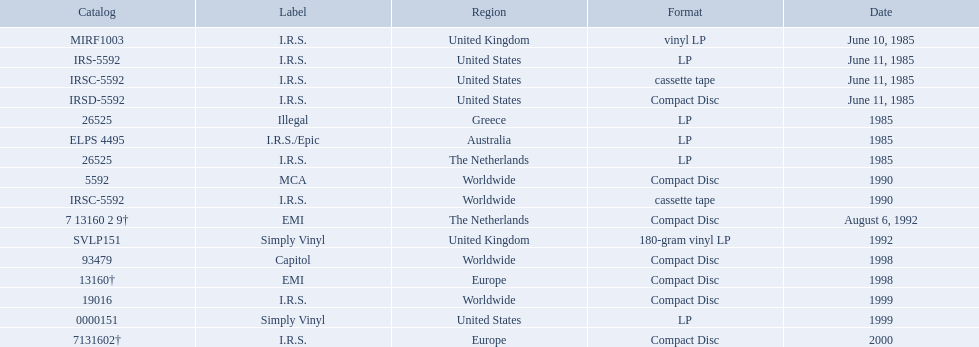Which dates were their releases by fables of the reconstruction? June 10, 1985, June 11, 1985, June 11, 1985, June 11, 1985, 1985, 1985, 1985, 1990, 1990, August 6, 1992, 1992, 1998, 1998, 1999, 1999, 2000. Which of these are in 1985? June 10, 1985, June 11, 1985, June 11, 1985, June 11, 1985, 1985, 1985, 1985. What regions were there releases on these dates? United Kingdom, United States, United States, United States, Greece, Australia, The Netherlands. Which of these are not greece? United Kingdom, United States, United States, United States, Australia, The Netherlands. Which of these regions have two labels listed? Australia. 